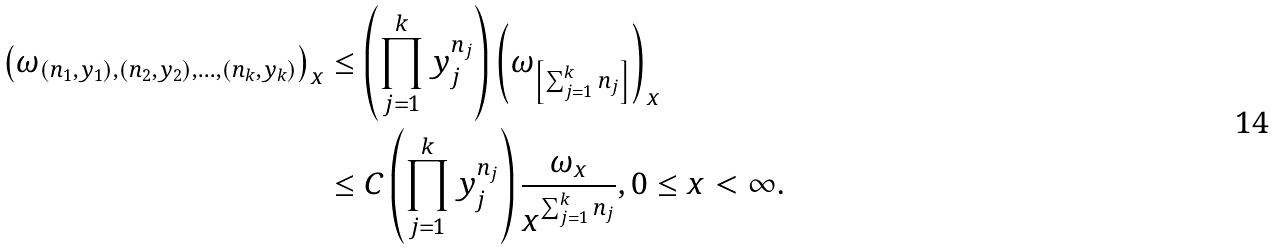<formula> <loc_0><loc_0><loc_500><loc_500>\left ( \omega _ { ( n _ { 1 } , y _ { 1 } ) , ( n _ { 2 } , y _ { 2 } ) , \dots , ( n _ { k } , y _ { k } ) } \right ) _ { x } & \leq \left ( \prod _ { j = 1 } ^ { k } y _ { j } ^ { n _ { j } } \right ) \left ( \omega _ { \left [ \sum _ { j = 1 } ^ { k } n _ { j } \right ] } \right ) _ { x } \\ & \leq C \left ( \prod _ { j = 1 } ^ { k } y _ { j } ^ { n _ { j } } \right ) \frac { \omega _ { x } } { x ^ { \sum _ { j = 1 } ^ { k } n _ { j } } } , 0 \leq x < \infty .</formula> 